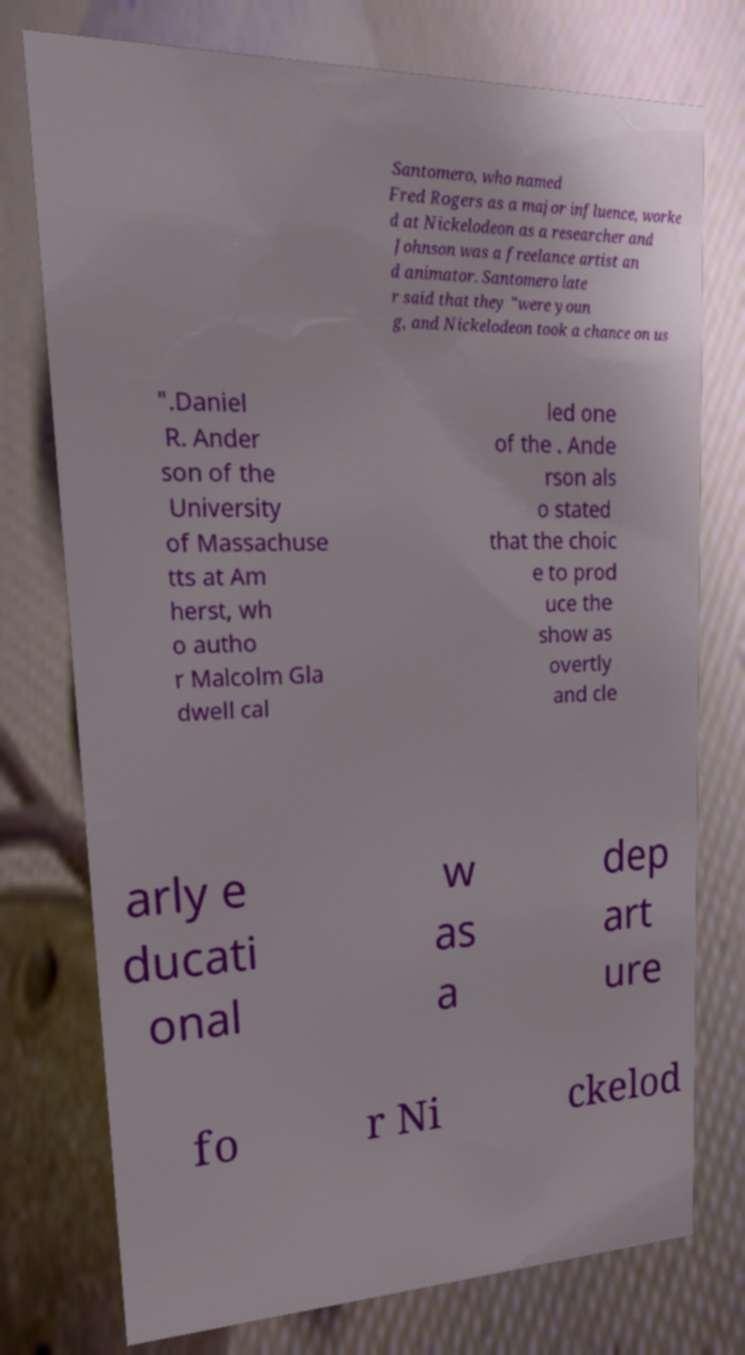Please identify and transcribe the text found in this image. Santomero, who named Fred Rogers as a major influence, worke d at Nickelodeon as a researcher and Johnson was a freelance artist an d animator. Santomero late r said that they "were youn g, and Nickelodeon took a chance on us ".Daniel R. Ander son of the University of Massachuse tts at Am herst, wh o autho r Malcolm Gla dwell cal led one of the . Ande rson als o stated that the choic e to prod uce the show as overtly and cle arly e ducati onal w as a dep art ure fo r Ni ckelod 